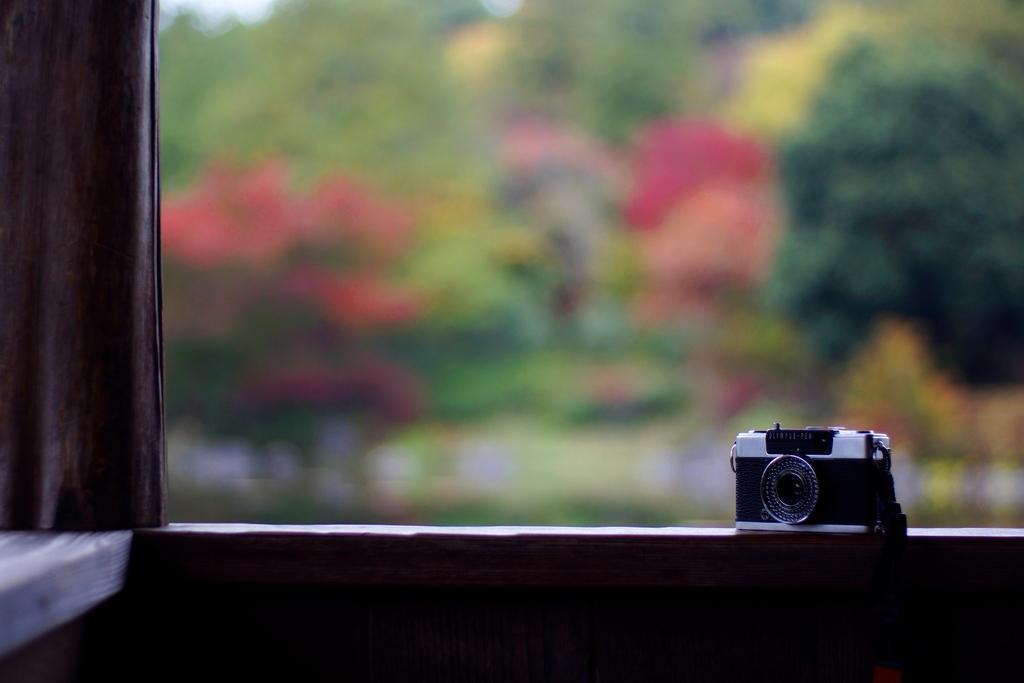Describe this image in one or two sentences. In the picture I can see a camera on a surface. On the left side I can see a cloth. The background of the image is blurred. 